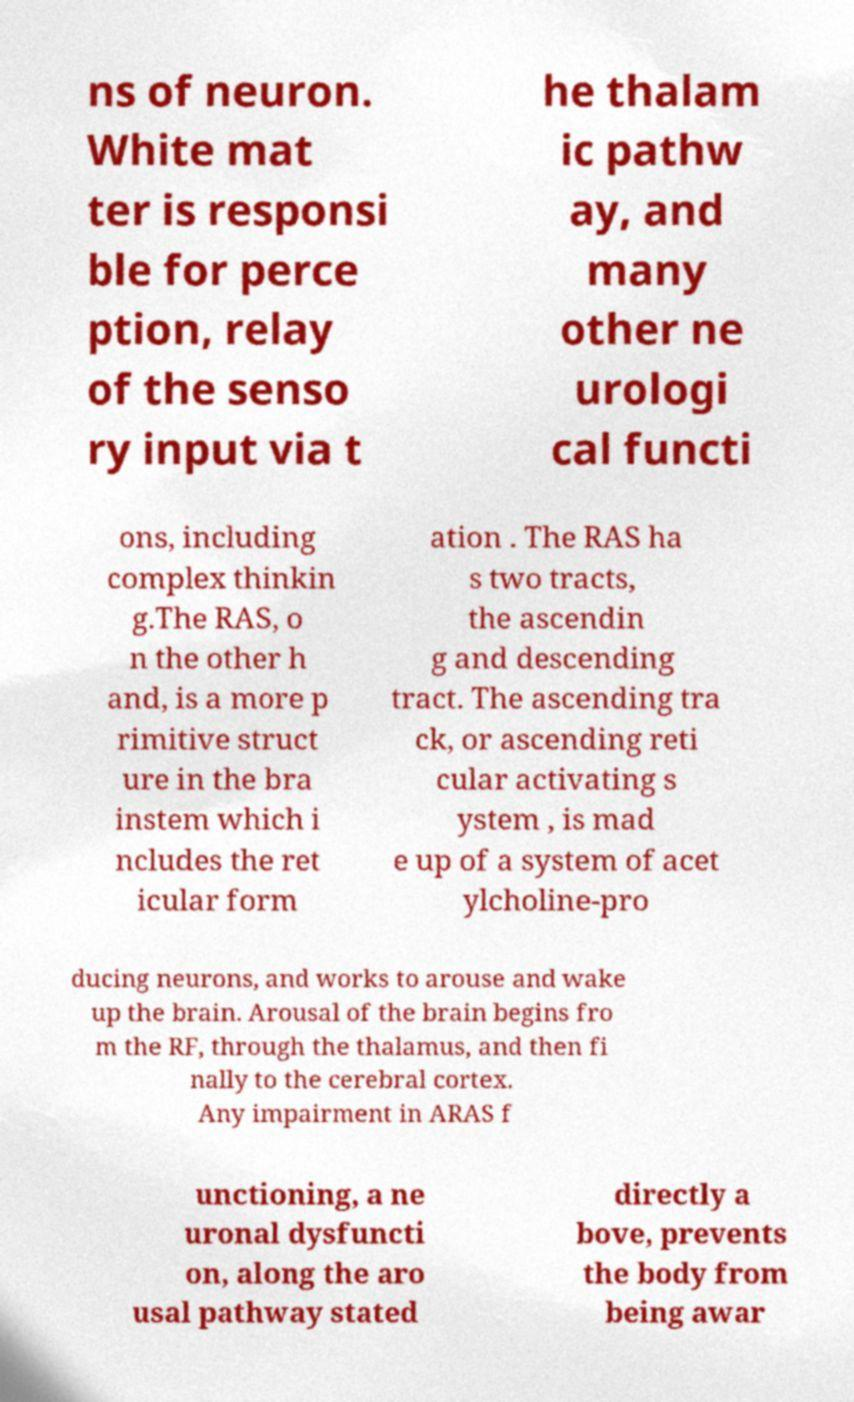For documentation purposes, I need the text within this image transcribed. Could you provide that? ns of neuron. White mat ter is responsi ble for perce ption, relay of the senso ry input via t he thalam ic pathw ay, and many other ne urologi cal functi ons, including complex thinkin g.The RAS, o n the other h and, is a more p rimitive struct ure in the bra instem which i ncludes the ret icular form ation . The RAS ha s two tracts, the ascendin g and descending tract. The ascending tra ck, or ascending reti cular activating s ystem , is mad e up of a system of acet ylcholine-pro ducing neurons, and works to arouse and wake up the brain. Arousal of the brain begins fro m the RF, through the thalamus, and then fi nally to the cerebral cortex. Any impairment in ARAS f unctioning, a ne uronal dysfuncti on, along the aro usal pathway stated directly a bove, prevents the body from being awar 